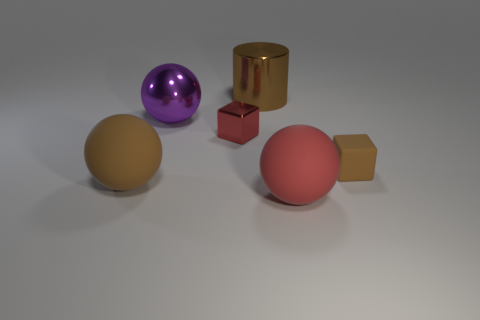Are there any other things that have the same shape as the large red rubber thing?
Offer a terse response. Yes. Are there fewer small cubes than tiny brown rubber cubes?
Keep it short and to the point. No. The big object that is both to the left of the small red metal cube and behind the shiny block is made of what material?
Make the answer very short. Metal. Are there any tiny red cubes behind the large brown thing behind the small rubber thing?
Give a very brief answer. No. How many things are small purple cylinders or tiny red objects?
Ensure brevity in your answer.  1. There is a large object that is to the left of the big brown metallic cylinder and to the right of the brown ball; what is its shape?
Your response must be concise. Sphere. Are the red thing on the left side of the large red sphere and the big brown ball made of the same material?
Your answer should be compact. No. What number of objects are either big shiny balls or blocks that are to the right of the brown shiny cylinder?
Your answer should be very brief. 2. There is a cube that is made of the same material as the purple ball; what is its color?
Offer a terse response. Red. What number of purple spheres are the same material as the brown sphere?
Provide a short and direct response. 0. 